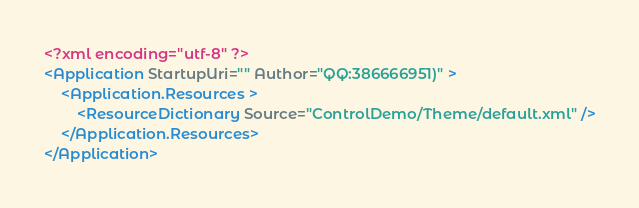<code> <loc_0><loc_0><loc_500><loc_500><_XML_><?xml encoding="utf-8" ?>
<Application StartupUri="" Author="QQ:386666951)" >
    <Application.Resources >
        <ResourceDictionary Source="ControlDemo/Theme/default.xml" />
    </Application.Resources>
</Application></code> 